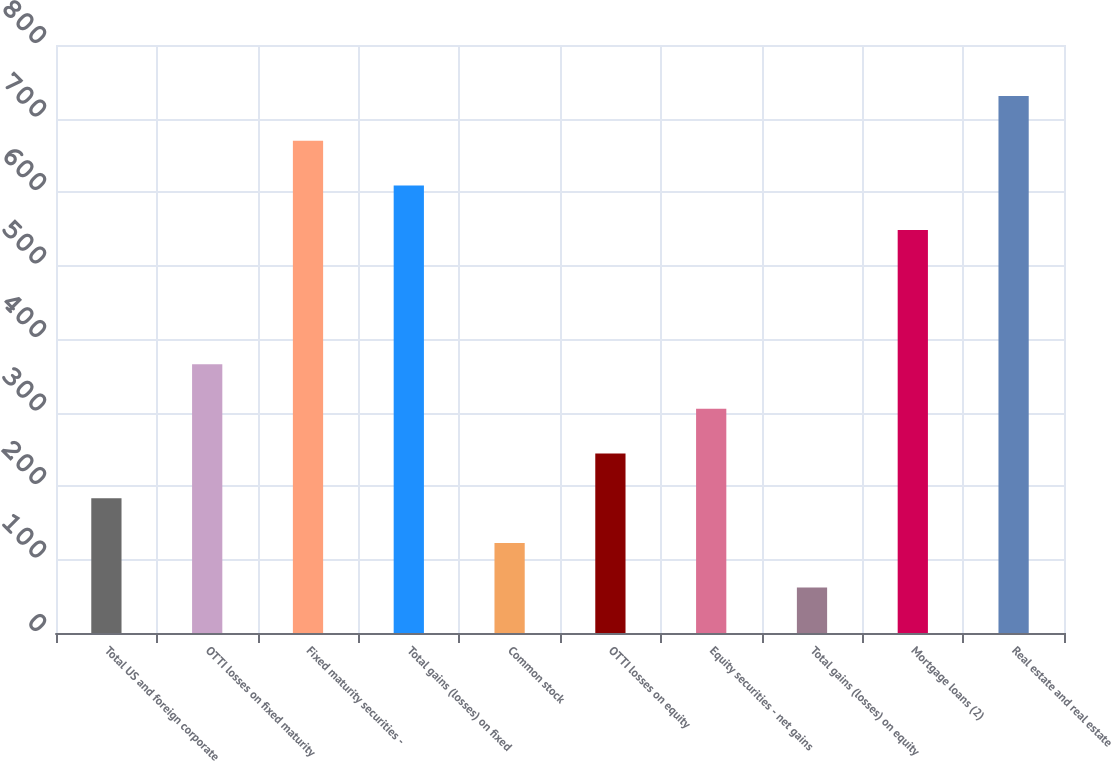<chart> <loc_0><loc_0><loc_500><loc_500><bar_chart><fcel>Total US and foreign corporate<fcel>OTTI losses on fixed maturity<fcel>Fixed maturity securities -<fcel>Total gains (losses) on fixed<fcel>Common stock<fcel>OTTI losses on equity<fcel>Equity securities - net gains<fcel>Total gains (losses) on equity<fcel>Mortgage loans (2)<fcel>Real estate and real estate<nl><fcel>183.4<fcel>365.8<fcel>669.8<fcel>609<fcel>122.6<fcel>244.2<fcel>305<fcel>61.8<fcel>548.2<fcel>730.6<nl></chart> 